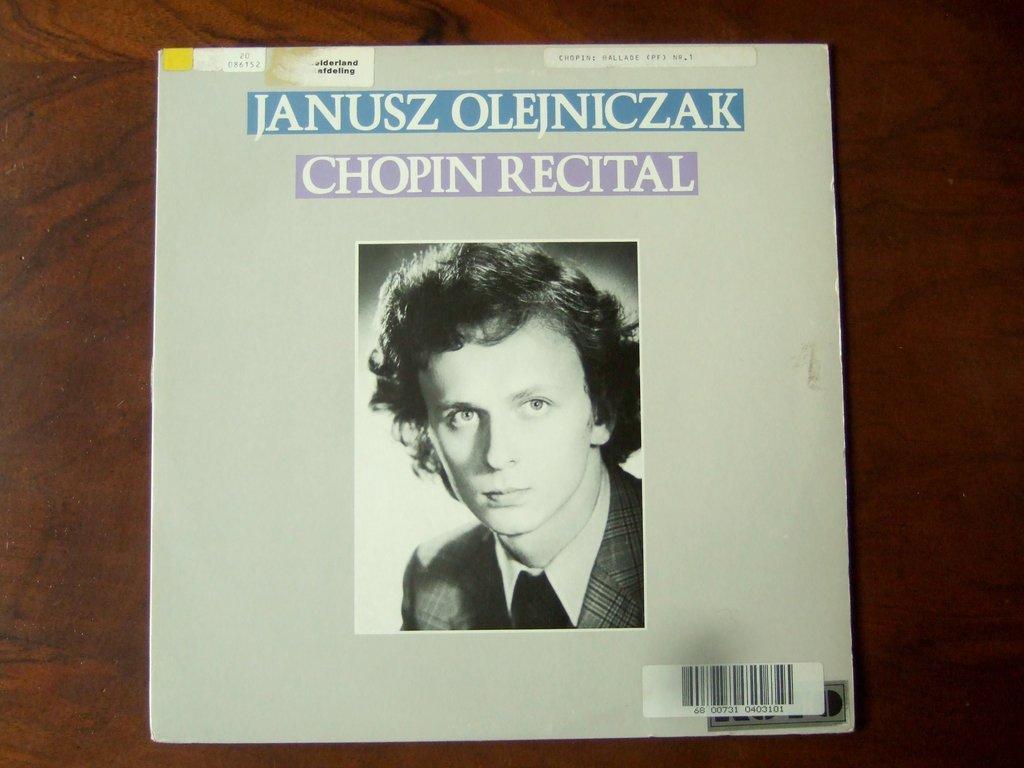Can you describe this image briefly? In this picture we can see a poster with a person and some text on it and this poster is on the wooden surface. 